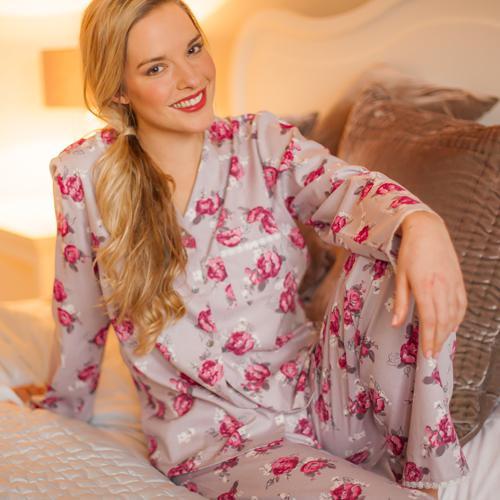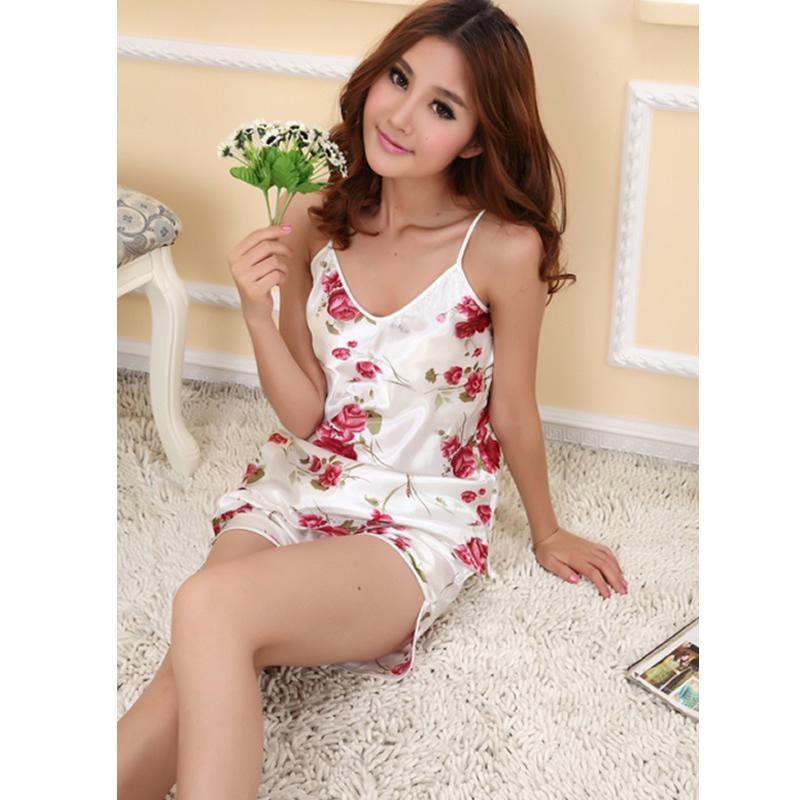The first image is the image on the left, the second image is the image on the right. For the images shown, is this caption "The woman in one of the images has at least one hand on her knee." true? Answer yes or no. Yes. 